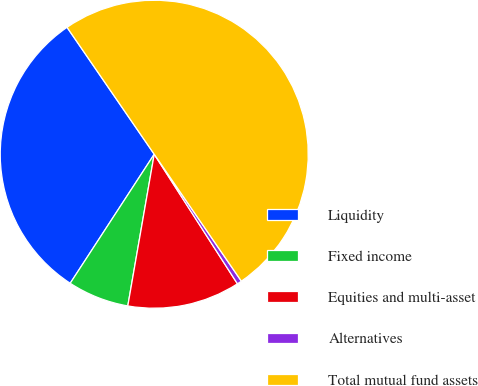Convert chart to OTSL. <chart><loc_0><loc_0><loc_500><loc_500><pie_chart><fcel>Liquidity<fcel>Fixed income<fcel>Equities and multi-asset<fcel>Alternatives<fcel>Total mutual fund assets<nl><fcel>31.23%<fcel>6.44%<fcel>11.83%<fcel>0.49%<fcel>50.0%<nl></chart> 